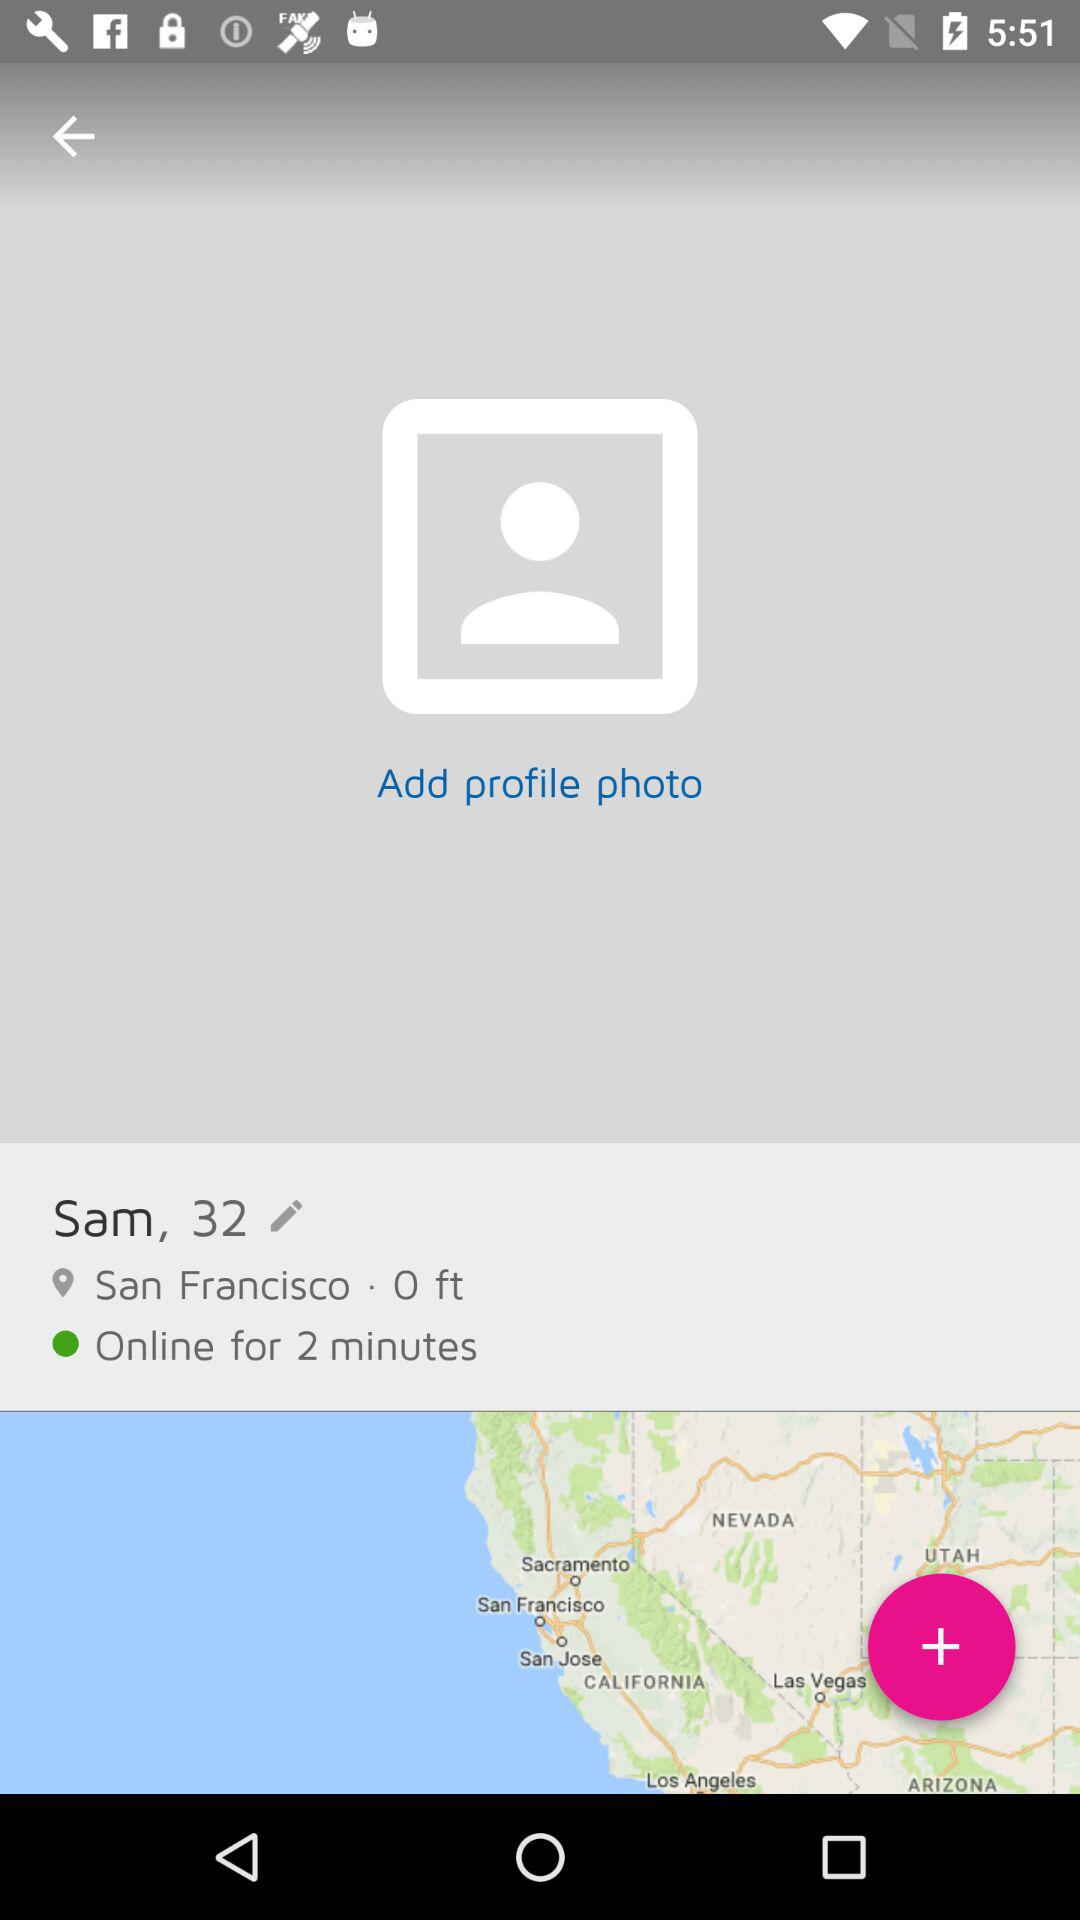Is the user online or offline? The user is online. 